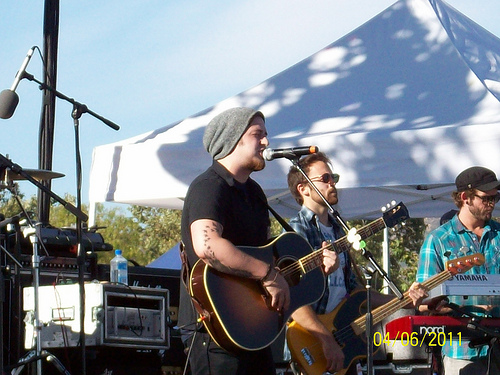<image>
Is there a guitar on the man? Yes. Looking at the image, I can see the guitar is positioned on top of the man, with the man providing support. Is the hat on the guitar? No. The hat is not positioned on the guitar. They may be near each other, but the hat is not supported by or resting on top of the guitar. Is there a man behind the mic? Yes. From this viewpoint, the man is positioned behind the mic, with the mic partially or fully occluding the man. 